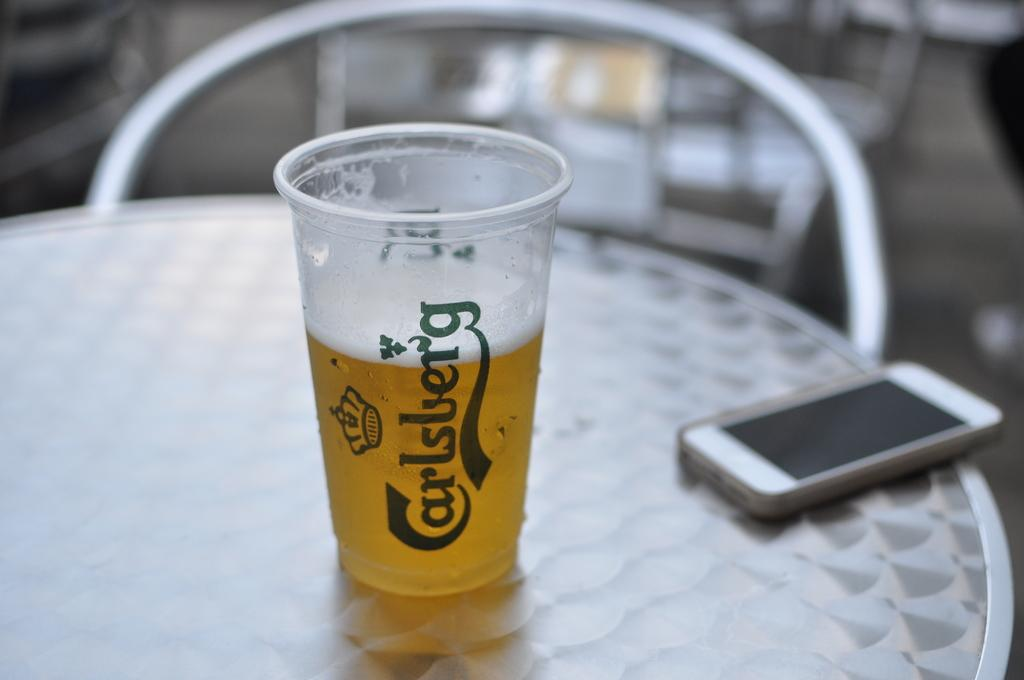Provide a one-sentence caption for the provided image. a plastic cup on a table that says 'carlsberg' in blue cursive. 